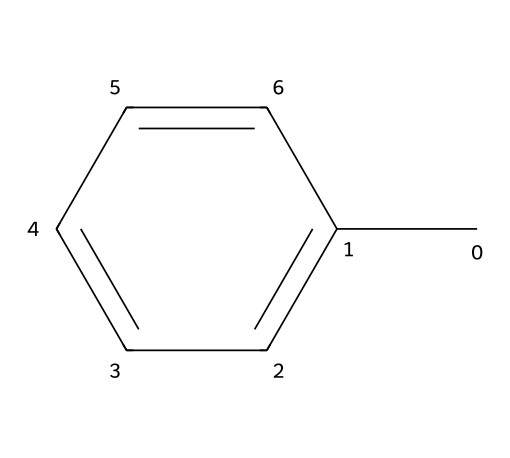How many carbon atoms are in toluene? The SMILES representation shows that there is a 'C' followed by 'c' indicating a carbon and a cyclic structure, which means there are 7 carbon atoms in total as indicated by the six aromatic carbon atoms in the benzene ring and one methyl group.
Answer: 7 What type of solvent is toluene classified as? Toluene is a common organic solvent used in various applications including electronics manufacturing, due to its ability to dissolve many substances.
Answer: organic What is the molecular formula of toluene? By interpreting the SMILES representation, we recognize that toluene consists of 7 carbon atoms and 8 hydrogen atoms (C7H8), yielding its molecular formula.
Answer: C7H8 Is toluene a hazardous chemical? Yes, toluene is classified as hazardous due to its potential health effects, including being an irritant and neurotoxin, which can affect the central nervous system upon exposure.
Answer: yes What type of bonding is predominant in toluene? The structure indicates covalent bonding, as it includes carbon-carbon and carbon-hydrogen bonds that are characteristic of organic compounds.
Answer: covalent Does the structure of toluene include any functional groups? The structure of toluene primarily features a methyl group (–CH3) attached to a benzene ring, making it part of the aromatic compound family but does not include other functional groups like hydroxyl or carboxyl.
Answer: no What physical state is toluene at room temperature? Given its properties as a common organic solvent, toluene is typically a liquid at room temperature, which is an important characteristic for its use in manufacturing.
Answer: liquid 